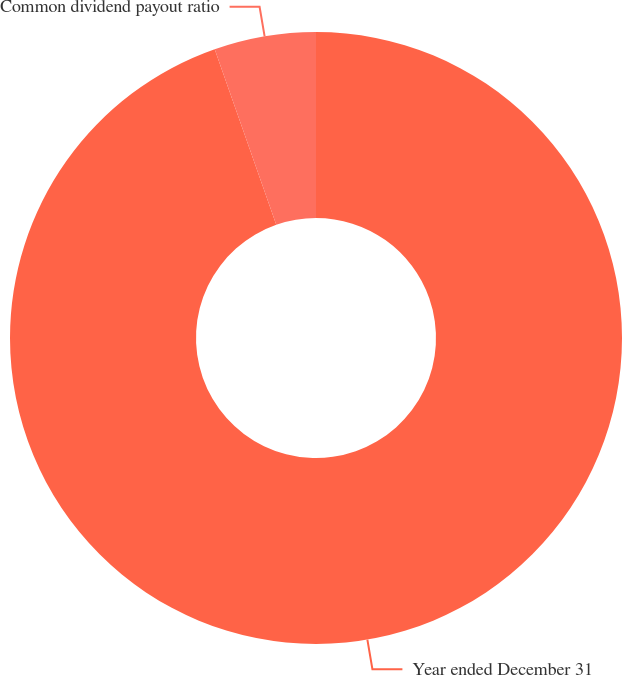<chart> <loc_0><loc_0><loc_500><loc_500><pie_chart><fcel>Year ended December 31<fcel>Common dividend payout ratio<nl><fcel>94.63%<fcel>5.37%<nl></chart> 